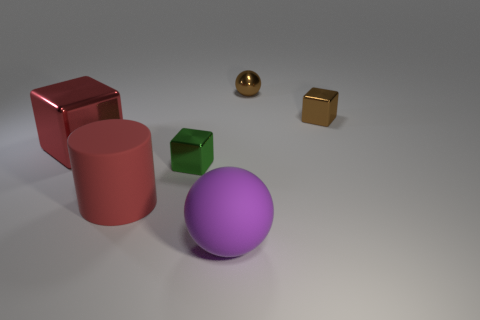Is there a pattern to the arrangement of the objects? There doesn't appear to be a strict pattern, but the objects are spaced out across the surface, which could suggest an intentional arrangement for display or comparison. 